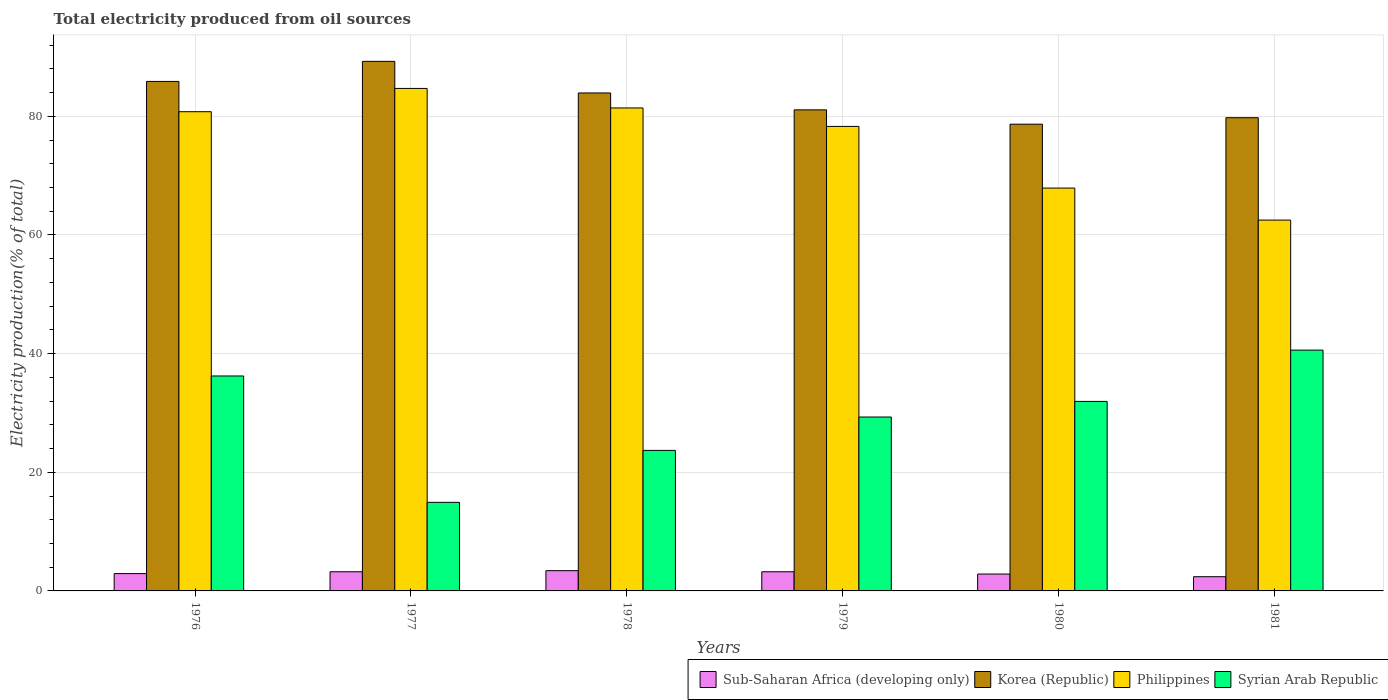How many different coloured bars are there?
Provide a succinct answer. 4. Are the number of bars on each tick of the X-axis equal?
Your answer should be compact. Yes. What is the label of the 6th group of bars from the left?
Offer a very short reply. 1981. In how many cases, is the number of bars for a given year not equal to the number of legend labels?
Ensure brevity in your answer.  0. What is the total electricity produced in Syrian Arab Republic in 1979?
Provide a short and direct response. 29.31. Across all years, what is the maximum total electricity produced in Philippines?
Ensure brevity in your answer.  84.7. Across all years, what is the minimum total electricity produced in Sub-Saharan Africa (developing only)?
Give a very brief answer. 2.39. In which year was the total electricity produced in Syrian Arab Republic maximum?
Keep it short and to the point. 1981. In which year was the total electricity produced in Korea (Republic) minimum?
Offer a very short reply. 1980. What is the total total electricity produced in Philippines in the graph?
Offer a terse response. 455.6. What is the difference between the total electricity produced in Korea (Republic) in 1976 and that in 1978?
Provide a short and direct response. 1.94. What is the difference between the total electricity produced in Sub-Saharan Africa (developing only) in 1981 and the total electricity produced in Philippines in 1980?
Provide a succinct answer. -65.51. What is the average total electricity produced in Philippines per year?
Offer a very short reply. 75.93. In the year 1977, what is the difference between the total electricity produced in Philippines and total electricity produced in Korea (Republic)?
Give a very brief answer. -4.56. What is the ratio of the total electricity produced in Philippines in 1976 to that in 1981?
Offer a terse response. 1.29. Is the difference between the total electricity produced in Philippines in 1979 and 1981 greater than the difference between the total electricity produced in Korea (Republic) in 1979 and 1981?
Your answer should be compact. Yes. What is the difference between the highest and the second highest total electricity produced in Philippines?
Ensure brevity in your answer.  3.29. What is the difference between the highest and the lowest total electricity produced in Philippines?
Offer a terse response. 22.19. Is the sum of the total electricity produced in Sub-Saharan Africa (developing only) in 1976 and 1980 greater than the maximum total electricity produced in Philippines across all years?
Keep it short and to the point. No. What does the 3rd bar from the right in 1976 represents?
Offer a terse response. Korea (Republic). What is the difference between two consecutive major ticks on the Y-axis?
Provide a succinct answer. 20. Are the values on the major ticks of Y-axis written in scientific E-notation?
Your answer should be very brief. No. Does the graph contain any zero values?
Give a very brief answer. No. Does the graph contain grids?
Provide a short and direct response. Yes. What is the title of the graph?
Provide a short and direct response. Total electricity produced from oil sources. What is the label or title of the X-axis?
Your answer should be compact. Years. What is the Electricity production(% of total) in Sub-Saharan Africa (developing only) in 1976?
Ensure brevity in your answer.  2.92. What is the Electricity production(% of total) of Korea (Republic) in 1976?
Offer a very short reply. 85.88. What is the Electricity production(% of total) in Philippines in 1976?
Offer a very short reply. 80.78. What is the Electricity production(% of total) of Syrian Arab Republic in 1976?
Offer a terse response. 36.23. What is the Electricity production(% of total) of Sub-Saharan Africa (developing only) in 1977?
Your response must be concise. 3.23. What is the Electricity production(% of total) of Korea (Republic) in 1977?
Offer a terse response. 89.27. What is the Electricity production(% of total) of Philippines in 1977?
Provide a short and direct response. 84.7. What is the Electricity production(% of total) of Syrian Arab Republic in 1977?
Offer a very short reply. 14.93. What is the Electricity production(% of total) in Sub-Saharan Africa (developing only) in 1978?
Offer a terse response. 3.41. What is the Electricity production(% of total) in Korea (Republic) in 1978?
Keep it short and to the point. 83.94. What is the Electricity production(% of total) of Philippines in 1978?
Provide a succinct answer. 81.41. What is the Electricity production(% of total) in Syrian Arab Republic in 1978?
Your answer should be compact. 23.69. What is the Electricity production(% of total) of Sub-Saharan Africa (developing only) in 1979?
Offer a terse response. 3.23. What is the Electricity production(% of total) of Korea (Republic) in 1979?
Provide a short and direct response. 81.09. What is the Electricity production(% of total) in Philippines in 1979?
Keep it short and to the point. 78.3. What is the Electricity production(% of total) in Syrian Arab Republic in 1979?
Make the answer very short. 29.31. What is the Electricity production(% of total) in Sub-Saharan Africa (developing only) in 1980?
Provide a short and direct response. 2.84. What is the Electricity production(% of total) of Korea (Republic) in 1980?
Offer a terse response. 78.67. What is the Electricity production(% of total) of Philippines in 1980?
Give a very brief answer. 67.9. What is the Electricity production(% of total) of Syrian Arab Republic in 1980?
Keep it short and to the point. 31.94. What is the Electricity production(% of total) of Sub-Saharan Africa (developing only) in 1981?
Offer a terse response. 2.39. What is the Electricity production(% of total) in Korea (Republic) in 1981?
Offer a very short reply. 79.76. What is the Electricity production(% of total) of Philippines in 1981?
Ensure brevity in your answer.  62.51. What is the Electricity production(% of total) in Syrian Arab Republic in 1981?
Your answer should be very brief. 40.59. Across all years, what is the maximum Electricity production(% of total) in Sub-Saharan Africa (developing only)?
Your answer should be very brief. 3.41. Across all years, what is the maximum Electricity production(% of total) in Korea (Republic)?
Keep it short and to the point. 89.27. Across all years, what is the maximum Electricity production(% of total) of Philippines?
Give a very brief answer. 84.7. Across all years, what is the maximum Electricity production(% of total) in Syrian Arab Republic?
Offer a very short reply. 40.59. Across all years, what is the minimum Electricity production(% of total) of Sub-Saharan Africa (developing only)?
Keep it short and to the point. 2.39. Across all years, what is the minimum Electricity production(% of total) in Korea (Republic)?
Give a very brief answer. 78.67. Across all years, what is the minimum Electricity production(% of total) in Philippines?
Make the answer very short. 62.51. Across all years, what is the minimum Electricity production(% of total) in Syrian Arab Republic?
Give a very brief answer. 14.93. What is the total Electricity production(% of total) of Sub-Saharan Africa (developing only) in the graph?
Offer a terse response. 18.04. What is the total Electricity production(% of total) in Korea (Republic) in the graph?
Your answer should be very brief. 498.61. What is the total Electricity production(% of total) in Philippines in the graph?
Provide a succinct answer. 455.6. What is the total Electricity production(% of total) of Syrian Arab Republic in the graph?
Offer a very short reply. 176.7. What is the difference between the Electricity production(% of total) in Sub-Saharan Africa (developing only) in 1976 and that in 1977?
Your response must be concise. -0.31. What is the difference between the Electricity production(% of total) of Korea (Republic) in 1976 and that in 1977?
Provide a succinct answer. -3.38. What is the difference between the Electricity production(% of total) in Philippines in 1976 and that in 1977?
Make the answer very short. -3.93. What is the difference between the Electricity production(% of total) in Syrian Arab Republic in 1976 and that in 1977?
Provide a short and direct response. 21.3. What is the difference between the Electricity production(% of total) of Sub-Saharan Africa (developing only) in 1976 and that in 1978?
Your answer should be very brief. -0.49. What is the difference between the Electricity production(% of total) in Korea (Republic) in 1976 and that in 1978?
Provide a short and direct response. 1.94. What is the difference between the Electricity production(% of total) in Philippines in 1976 and that in 1978?
Your answer should be compact. -0.64. What is the difference between the Electricity production(% of total) of Syrian Arab Republic in 1976 and that in 1978?
Ensure brevity in your answer.  12.55. What is the difference between the Electricity production(% of total) in Sub-Saharan Africa (developing only) in 1976 and that in 1979?
Offer a terse response. -0.31. What is the difference between the Electricity production(% of total) in Korea (Republic) in 1976 and that in 1979?
Ensure brevity in your answer.  4.79. What is the difference between the Electricity production(% of total) of Philippines in 1976 and that in 1979?
Your answer should be very brief. 2.48. What is the difference between the Electricity production(% of total) in Syrian Arab Republic in 1976 and that in 1979?
Your answer should be very brief. 6.92. What is the difference between the Electricity production(% of total) of Sub-Saharan Africa (developing only) in 1976 and that in 1980?
Your answer should be very brief. 0.08. What is the difference between the Electricity production(% of total) in Korea (Republic) in 1976 and that in 1980?
Offer a terse response. 7.21. What is the difference between the Electricity production(% of total) of Philippines in 1976 and that in 1980?
Ensure brevity in your answer.  12.87. What is the difference between the Electricity production(% of total) of Syrian Arab Republic in 1976 and that in 1980?
Provide a short and direct response. 4.29. What is the difference between the Electricity production(% of total) of Sub-Saharan Africa (developing only) in 1976 and that in 1981?
Provide a succinct answer. 0.53. What is the difference between the Electricity production(% of total) in Korea (Republic) in 1976 and that in 1981?
Give a very brief answer. 6.12. What is the difference between the Electricity production(% of total) in Philippines in 1976 and that in 1981?
Provide a succinct answer. 18.27. What is the difference between the Electricity production(% of total) in Syrian Arab Republic in 1976 and that in 1981?
Ensure brevity in your answer.  -4.36. What is the difference between the Electricity production(% of total) in Sub-Saharan Africa (developing only) in 1977 and that in 1978?
Give a very brief answer. -0.19. What is the difference between the Electricity production(% of total) of Korea (Republic) in 1977 and that in 1978?
Your answer should be compact. 5.33. What is the difference between the Electricity production(% of total) in Philippines in 1977 and that in 1978?
Provide a short and direct response. 3.29. What is the difference between the Electricity production(% of total) of Syrian Arab Republic in 1977 and that in 1978?
Keep it short and to the point. -8.76. What is the difference between the Electricity production(% of total) in Sub-Saharan Africa (developing only) in 1977 and that in 1979?
Offer a terse response. 0. What is the difference between the Electricity production(% of total) in Korea (Republic) in 1977 and that in 1979?
Provide a succinct answer. 8.18. What is the difference between the Electricity production(% of total) of Philippines in 1977 and that in 1979?
Keep it short and to the point. 6.4. What is the difference between the Electricity production(% of total) in Syrian Arab Republic in 1977 and that in 1979?
Offer a very short reply. -14.38. What is the difference between the Electricity production(% of total) of Sub-Saharan Africa (developing only) in 1977 and that in 1980?
Your answer should be compact. 0.39. What is the difference between the Electricity production(% of total) in Korea (Republic) in 1977 and that in 1980?
Make the answer very short. 10.59. What is the difference between the Electricity production(% of total) of Philippines in 1977 and that in 1980?
Your answer should be compact. 16.8. What is the difference between the Electricity production(% of total) of Syrian Arab Republic in 1977 and that in 1980?
Your answer should be very brief. -17.02. What is the difference between the Electricity production(% of total) of Sub-Saharan Africa (developing only) in 1977 and that in 1981?
Ensure brevity in your answer.  0.84. What is the difference between the Electricity production(% of total) in Korea (Republic) in 1977 and that in 1981?
Provide a short and direct response. 9.5. What is the difference between the Electricity production(% of total) in Philippines in 1977 and that in 1981?
Keep it short and to the point. 22.19. What is the difference between the Electricity production(% of total) in Syrian Arab Republic in 1977 and that in 1981?
Make the answer very short. -25.66. What is the difference between the Electricity production(% of total) of Sub-Saharan Africa (developing only) in 1978 and that in 1979?
Your response must be concise. 0.19. What is the difference between the Electricity production(% of total) in Korea (Republic) in 1978 and that in 1979?
Your answer should be very brief. 2.85. What is the difference between the Electricity production(% of total) in Philippines in 1978 and that in 1979?
Offer a very short reply. 3.11. What is the difference between the Electricity production(% of total) of Syrian Arab Republic in 1978 and that in 1979?
Your answer should be compact. -5.63. What is the difference between the Electricity production(% of total) in Sub-Saharan Africa (developing only) in 1978 and that in 1980?
Offer a very short reply. 0.57. What is the difference between the Electricity production(% of total) of Korea (Republic) in 1978 and that in 1980?
Give a very brief answer. 5.27. What is the difference between the Electricity production(% of total) in Philippines in 1978 and that in 1980?
Keep it short and to the point. 13.51. What is the difference between the Electricity production(% of total) in Syrian Arab Republic in 1978 and that in 1980?
Make the answer very short. -8.26. What is the difference between the Electricity production(% of total) in Sub-Saharan Africa (developing only) in 1978 and that in 1981?
Offer a terse response. 1.02. What is the difference between the Electricity production(% of total) in Korea (Republic) in 1978 and that in 1981?
Your answer should be compact. 4.17. What is the difference between the Electricity production(% of total) of Philippines in 1978 and that in 1981?
Keep it short and to the point. 18.9. What is the difference between the Electricity production(% of total) of Syrian Arab Republic in 1978 and that in 1981?
Offer a terse response. -16.91. What is the difference between the Electricity production(% of total) of Sub-Saharan Africa (developing only) in 1979 and that in 1980?
Provide a short and direct response. 0.38. What is the difference between the Electricity production(% of total) in Korea (Republic) in 1979 and that in 1980?
Provide a succinct answer. 2.42. What is the difference between the Electricity production(% of total) of Philippines in 1979 and that in 1980?
Ensure brevity in your answer.  10.39. What is the difference between the Electricity production(% of total) in Syrian Arab Republic in 1979 and that in 1980?
Provide a succinct answer. -2.63. What is the difference between the Electricity production(% of total) of Sub-Saharan Africa (developing only) in 1979 and that in 1981?
Your answer should be very brief. 0.84. What is the difference between the Electricity production(% of total) in Korea (Republic) in 1979 and that in 1981?
Your answer should be very brief. 1.33. What is the difference between the Electricity production(% of total) in Philippines in 1979 and that in 1981?
Keep it short and to the point. 15.79. What is the difference between the Electricity production(% of total) in Syrian Arab Republic in 1979 and that in 1981?
Offer a terse response. -11.28. What is the difference between the Electricity production(% of total) in Sub-Saharan Africa (developing only) in 1980 and that in 1981?
Your answer should be very brief. 0.45. What is the difference between the Electricity production(% of total) in Korea (Republic) in 1980 and that in 1981?
Your answer should be very brief. -1.09. What is the difference between the Electricity production(% of total) in Philippines in 1980 and that in 1981?
Your answer should be very brief. 5.4. What is the difference between the Electricity production(% of total) of Syrian Arab Republic in 1980 and that in 1981?
Your answer should be very brief. -8.65. What is the difference between the Electricity production(% of total) of Sub-Saharan Africa (developing only) in 1976 and the Electricity production(% of total) of Korea (Republic) in 1977?
Offer a very short reply. -86.34. What is the difference between the Electricity production(% of total) in Sub-Saharan Africa (developing only) in 1976 and the Electricity production(% of total) in Philippines in 1977?
Offer a very short reply. -81.78. What is the difference between the Electricity production(% of total) in Sub-Saharan Africa (developing only) in 1976 and the Electricity production(% of total) in Syrian Arab Republic in 1977?
Make the answer very short. -12.01. What is the difference between the Electricity production(% of total) in Korea (Republic) in 1976 and the Electricity production(% of total) in Philippines in 1977?
Your answer should be compact. 1.18. What is the difference between the Electricity production(% of total) in Korea (Republic) in 1976 and the Electricity production(% of total) in Syrian Arab Republic in 1977?
Make the answer very short. 70.95. What is the difference between the Electricity production(% of total) of Philippines in 1976 and the Electricity production(% of total) of Syrian Arab Republic in 1977?
Offer a terse response. 65.85. What is the difference between the Electricity production(% of total) in Sub-Saharan Africa (developing only) in 1976 and the Electricity production(% of total) in Korea (Republic) in 1978?
Your answer should be compact. -81.02. What is the difference between the Electricity production(% of total) in Sub-Saharan Africa (developing only) in 1976 and the Electricity production(% of total) in Philippines in 1978?
Make the answer very short. -78.49. What is the difference between the Electricity production(% of total) of Sub-Saharan Africa (developing only) in 1976 and the Electricity production(% of total) of Syrian Arab Republic in 1978?
Ensure brevity in your answer.  -20.76. What is the difference between the Electricity production(% of total) in Korea (Republic) in 1976 and the Electricity production(% of total) in Philippines in 1978?
Your answer should be compact. 4.47. What is the difference between the Electricity production(% of total) in Korea (Republic) in 1976 and the Electricity production(% of total) in Syrian Arab Republic in 1978?
Offer a terse response. 62.2. What is the difference between the Electricity production(% of total) of Philippines in 1976 and the Electricity production(% of total) of Syrian Arab Republic in 1978?
Provide a short and direct response. 57.09. What is the difference between the Electricity production(% of total) in Sub-Saharan Africa (developing only) in 1976 and the Electricity production(% of total) in Korea (Republic) in 1979?
Make the answer very short. -78.17. What is the difference between the Electricity production(% of total) of Sub-Saharan Africa (developing only) in 1976 and the Electricity production(% of total) of Philippines in 1979?
Your answer should be very brief. -75.38. What is the difference between the Electricity production(% of total) of Sub-Saharan Africa (developing only) in 1976 and the Electricity production(% of total) of Syrian Arab Republic in 1979?
Offer a very short reply. -26.39. What is the difference between the Electricity production(% of total) in Korea (Republic) in 1976 and the Electricity production(% of total) in Philippines in 1979?
Provide a short and direct response. 7.58. What is the difference between the Electricity production(% of total) of Korea (Republic) in 1976 and the Electricity production(% of total) of Syrian Arab Republic in 1979?
Ensure brevity in your answer.  56.57. What is the difference between the Electricity production(% of total) in Philippines in 1976 and the Electricity production(% of total) in Syrian Arab Republic in 1979?
Your answer should be compact. 51.46. What is the difference between the Electricity production(% of total) of Sub-Saharan Africa (developing only) in 1976 and the Electricity production(% of total) of Korea (Republic) in 1980?
Ensure brevity in your answer.  -75.75. What is the difference between the Electricity production(% of total) in Sub-Saharan Africa (developing only) in 1976 and the Electricity production(% of total) in Philippines in 1980?
Your answer should be compact. -64.98. What is the difference between the Electricity production(% of total) of Sub-Saharan Africa (developing only) in 1976 and the Electricity production(% of total) of Syrian Arab Republic in 1980?
Offer a very short reply. -29.02. What is the difference between the Electricity production(% of total) in Korea (Republic) in 1976 and the Electricity production(% of total) in Philippines in 1980?
Provide a short and direct response. 17.98. What is the difference between the Electricity production(% of total) in Korea (Republic) in 1976 and the Electricity production(% of total) in Syrian Arab Republic in 1980?
Your answer should be very brief. 53.94. What is the difference between the Electricity production(% of total) in Philippines in 1976 and the Electricity production(% of total) in Syrian Arab Republic in 1980?
Provide a succinct answer. 48.83. What is the difference between the Electricity production(% of total) of Sub-Saharan Africa (developing only) in 1976 and the Electricity production(% of total) of Korea (Republic) in 1981?
Ensure brevity in your answer.  -76.84. What is the difference between the Electricity production(% of total) of Sub-Saharan Africa (developing only) in 1976 and the Electricity production(% of total) of Philippines in 1981?
Keep it short and to the point. -59.59. What is the difference between the Electricity production(% of total) in Sub-Saharan Africa (developing only) in 1976 and the Electricity production(% of total) in Syrian Arab Republic in 1981?
Provide a succinct answer. -37.67. What is the difference between the Electricity production(% of total) in Korea (Republic) in 1976 and the Electricity production(% of total) in Philippines in 1981?
Give a very brief answer. 23.37. What is the difference between the Electricity production(% of total) in Korea (Republic) in 1976 and the Electricity production(% of total) in Syrian Arab Republic in 1981?
Provide a short and direct response. 45.29. What is the difference between the Electricity production(% of total) of Philippines in 1976 and the Electricity production(% of total) of Syrian Arab Republic in 1981?
Offer a very short reply. 40.18. What is the difference between the Electricity production(% of total) of Sub-Saharan Africa (developing only) in 1977 and the Electricity production(% of total) of Korea (Republic) in 1978?
Your response must be concise. -80.71. What is the difference between the Electricity production(% of total) in Sub-Saharan Africa (developing only) in 1977 and the Electricity production(% of total) in Philippines in 1978?
Keep it short and to the point. -78.18. What is the difference between the Electricity production(% of total) of Sub-Saharan Africa (developing only) in 1977 and the Electricity production(% of total) of Syrian Arab Republic in 1978?
Provide a short and direct response. -20.46. What is the difference between the Electricity production(% of total) in Korea (Republic) in 1977 and the Electricity production(% of total) in Philippines in 1978?
Your response must be concise. 7.85. What is the difference between the Electricity production(% of total) of Korea (Republic) in 1977 and the Electricity production(% of total) of Syrian Arab Republic in 1978?
Ensure brevity in your answer.  65.58. What is the difference between the Electricity production(% of total) of Philippines in 1977 and the Electricity production(% of total) of Syrian Arab Republic in 1978?
Keep it short and to the point. 61.02. What is the difference between the Electricity production(% of total) in Sub-Saharan Africa (developing only) in 1977 and the Electricity production(% of total) in Korea (Republic) in 1979?
Ensure brevity in your answer.  -77.86. What is the difference between the Electricity production(% of total) of Sub-Saharan Africa (developing only) in 1977 and the Electricity production(% of total) of Philippines in 1979?
Ensure brevity in your answer.  -75.07. What is the difference between the Electricity production(% of total) in Sub-Saharan Africa (developing only) in 1977 and the Electricity production(% of total) in Syrian Arab Republic in 1979?
Your answer should be compact. -26.08. What is the difference between the Electricity production(% of total) in Korea (Republic) in 1977 and the Electricity production(% of total) in Philippines in 1979?
Your answer should be compact. 10.97. What is the difference between the Electricity production(% of total) in Korea (Republic) in 1977 and the Electricity production(% of total) in Syrian Arab Republic in 1979?
Provide a succinct answer. 59.95. What is the difference between the Electricity production(% of total) of Philippines in 1977 and the Electricity production(% of total) of Syrian Arab Republic in 1979?
Provide a short and direct response. 55.39. What is the difference between the Electricity production(% of total) of Sub-Saharan Africa (developing only) in 1977 and the Electricity production(% of total) of Korea (Republic) in 1980?
Provide a short and direct response. -75.44. What is the difference between the Electricity production(% of total) of Sub-Saharan Africa (developing only) in 1977 and the Electricity production(% of total) of Philippines in 1980?
Offer a terse response. -64.68. What is the difference between the Electricity production(% of total) in Sub-Saharan Africa (developing only) in 1977 and the Electricity production(% of total) in Syrian Arab Republic in 1980?
Offer a terse response. -28.71. What is the difference between the Electricity production(% of total) in Korea (Republic) in 1977 and the Electricity production(% of total) in Philippines in 1980?
Make the answer very short. 21.36. What is the difference between the Electricity production(% of total) of Korea (Republic) in 1977 and the Electricity production(% of total) of Syrian Arab Republic in 1980?
Offer a very short reply. 57.32. What is the difference between the Electricity production(% of total) in Philippines in 1977 and the Electricity production(% of total) in Syrian Arab Republic in 1980?
Your answer should be very brief. 52.76. What is the difference between the Electricity production(% of total) in Sub-Saharan Africa (developing only) in 1977 and the Electricity production(% of total) in Korea (Republic) in 1981?
Provide a short and direct response. -76.54. What is the difference between the Electricity production(% of total) of Sub-Saharan Africa (developing only) in 1977 and the Electricity production(% of total) of Philippines in 1981?
Provide a succinct answer. -59.28. What is the difference between the Electricity production(% of total) in Sub-Saharan Africa (developing only) in 1977 and the Electricity production(% of total) in Syrian Arab Republic in 1981?
Your answer should be very brief. -37.36. What is the difference between the Electricity production(% of total) of Korea (Republic) in 1977 and the Electricity production(% of total) of Philippines in 1981?
Your answer should be compact. 26.76. What is the difference between the Electricity production(% of total) of Korea (Republic) in 1977 and the Electricity production(% of total) of Syrian Arab Republic in 1981?
Your response must be concise. 48.67. What is the difference between the Electricity production(% of total) of Philippines in 1977 and the Electricity production(% of total) of Syrian Arab Republic in 1981?
Make the answer very short. 44.11. What is the difference between the Electricity production(% of total) in Sub-Saharan Africa (developing only) in 1978 and the Electricity production(% of total) in Korea (Republic) in 1979?
Make the answer very short. -77.68. What is the difference between the Electricity production(% of total) in Sub-Saharan Africa (developing only) in 1978 and the Electricity production(% of total) in Philippines in 1979?
Your response must be concise. -74.88. What is the difference between the Electricity production(% of total) of Sub-Saharan Africa (developing only) in 1978 and the Electricity production(% of total) of Syrian Arab Republic in 1979?
Provide a short and direct response. -25.9. What is the difference between the Electricity production(% of total) of Korea (Republic) in 1978 and the Electricity production(% of total) of Philippines in 1979?
Keep it short and to the point. 5.64. What is the difference between the Electricity production(% of total) in Korea (Republic) in 1978 and the Electricity production(% of total) in Syrian Arab Republic in 1979?
Your answer should be compact. 54.63. What is the difference between the Electricity production(% of total) of Philippines in 1978 and the Electricity production(% of total) of Syrian Arab Republic in 1979?
Your answer should be very brief. 52.1. What is the difference between the Electricity production(% of total) of Sub-Saharan Africa (developing only) in 1978 and the Electricity production(% of total) of Korea (Republic) in 1980?
Provide a succinct answer. -75.26. What is the difference between the Electricity production(% of total) of Sub-Saharan Africa (developing only) in 1978 and the Electricity production(% of total) of Philippines in 1980?
Provide a short and direct response. -64.49. What is the difference between the Electricity production(% of total) of Sub-Saharan Africa (developing only) in 1978 and the Electricity production(% of total) of Syrian Arab Republic in 1980?
Give a very brief answer. -28.53. What is the difference between the Electricity production(% of total) in Korea (Republic) in 1978 and the Electricity production(% of total) in Philippines in 1980?
Your answer should be very brief. 16.03. What is the difference between the Electricity production(% of total) in Korea (Republic) in 1978 and the Electricity production(% of total) in Syrian Arab Republic in 1980?
Offer a very short reply. 51.99. What is the difference between the Electricity production(% of total) of Philippines in 1978 and the Electricity production(% of total) of Syrian Arab Republic in 1980?
Keep it short and to the point. 49.47. What is the difference between the Electricity production(% of total) of Sub-Saharan Africa (developing only) in 1978 and the Electricity production(% of total) of Korea (Republic) in 1981?
Your answer should be compact. -76.35. What is the difference between the Electricity production(% of total) in Sub-Saharan Africa (developing only) in 1978 and the Electricity production(% of total) in Philippines in 1981?
Keep it short and to the point. -59.09. What is the difference between the Electricity production(% of total) of Sub-Saharan Africa (developing only) in 1978 and the Electricity production(% of total) of Syrian Arab Republic in 1981?
Offer a very short reply. -37.18. What is the difference between the Electricity production(% of total) of Korea (Republic) in 1978 and the Electricity production(% of total) of Philippines in 1981?
Offer a very short reply. 21.43. What is the difference between the Electricity production(% of total) of Korea (Republic) in 1978 and the Electricity production(% of total) of Syrian Arab Republic in 1981?
Your answer should be very brief. 43.35. What is the difference between the Electricity production(% of total) in Philippines in 1978 and the Electricity production(% of total) in Syrian Arab Republic in 1981?
Your answer should be very brief. 40.82. What is the difference between the Electricity production(% of total) of Sub-Saharan Africa (developing only) in 1979 and the Electricity production(% of total) of Korea (Republic) in 1980?
Offer a very short reply. -75.44. What is the difference between the Electricity production(% of total) of Sub-Saharan Africa (developing only) in 1979 and the Electricity production(% of total) of Philippines in 1980?
Keep it short and to the point. -64.68. What is the difference between the Electricity production(% of total) in Sub-Saharan Africa (developing only) in 1979 and the Electricity production(% of total) in Syrian Arab Republic in 1980?
Give a very brief answer. -28.72. What is the difference between the Electricity production(% of total) in Korea (Republic) in 1979 and the Electricity production(% of total) in Philippines in 1980?
Make the answer very short. 13.19. What is the difference between the Electricity production(% of total) in Korea (Republic) in 1979 and the Electricity production(% of total) in Syrian Arab Republic in 1980?
Offer a terse response. 49.15. What is the difference between the Electricity production(% of total) in Philippines in 1979 and the Electricity production(% of total) in Syrian Arab Republic in 1980?
Ensure brevity in your answer.  46.35. What is the difference between the Electricity production(% of total) in Sub-Saharan Africa (developing only) in 1979 and the Electricity production(% of total) in Korea (Republic) in 1981?
Give a very brief answer. -76.54. What is the difference between the Electricity production(% of total) in Sub-Saharan Africa (developing only) in 1979 and the Electricity production(% of total) in Philippines in 1981?
Offer a very short reply. -59.28. What is the difference between the Electricity production(% of total) in Sub-Saharan Africa (developing only) in 1979 and the Electricity production(% of total) in Syrian Arab Republic in 1981?
Ensure brevity in your answer.  -37.36. What is the difference between the Electricity production(% of total) of Korea (Republic) in 1979 and the Electricity production(% of total) of Philippines in 1981?
Provide a succinct answer. 18.58. What is the difference between the Electricity production(% of total) of Korea (Republic) in 1979 and the Electricity production(% of total) of Syrian Arab Republic in 1981?
Provide a succinct answer. 40.5. What is the difference between the Electricity production(% of total) in Philippines in 1979 and the Electricity production(% of total) in Syrian Arab Republic in 1981?
Your response must be concise. 37.71. What is the difference between the Electricity production(% of total) in Sub-Saharan Africa (developing only) in 1980 and the Electricity production(% of total) in Korea (Republic) in 1981?
Provide a succinct answer. -76.92. What is the difference between the Electricity production(% of total) in Sub-Saharan Africa (developing only) in 1980 and the Electricity production(% of total) in Philippines in 1981?
Offer a terse response. -59.66. What is the difference between the Electricity production(% of total) in Sub-Saharan Africa (developing only) in 1980 and the Electricity production(% of total) in Syrian Arab Republic in 1981?
Make the answer very short. -37.75. What is the difference between the Electricity production(% of total) in Korea (Republic) in 1980 and the Electricity production(% of total) in Philippines in 1981?
Provide a succinct answer. 16.16. What is the difference between the Electricity production(% of total) of Korea (Republic) in 1980 and the Electricity production(% of total) of Syrian Arab Republic in 1981?
Offer a terse response. 38.08. What is the difference between the Electricity production(% of total) of Philippines in 1980 and the Electricity production(% of total) of Syrian Arab Republic in 1981?
Keep it short and to the point. 27.31. What is the average Electricity production(% of total) of Sub-Saharan Africa (developing only) per year?
Keep it short and to the point. 3.01. What is the average Electricity production(% of total) in Korea (Republic) per year?
Make the answer very short. 83.1. What is the average Electricity production(% of total) in Philippines per year?
Keep it short and to the point. 75.93. What is the average Electricity production(% of total) of Syrian Arab Republic per year?
Keep it short and to the point. 29.45. In the year 1976, what is the difference between the Electricity production(% of total) in Sub-Saharan Africa (developing only) and Electricity production(% of total) in Korea (Republic)?
Give a very brief answer. -82.96. In the year 1976, what is the difference between the Electricity production(% of total) of Sub-Saharan Africa (developing only) and Electricity production(% of total) of Philippines?
Your answer should be compact. -77.85. In the year 1976, what is the difference between the Electricity production(% of total) of Sub-Saharan Africa (developing only) and Electricity production(% of total) of Syrian Arab Republic?
Provide a succinct answer. -33.31. In the year 1976, what is the difference between the Electricity production(% of total) in Korea (Republic) and Electricity production(% of total) in Philippines?
Provide a short and direct response. 5.1. In the year 1976, what is the difference between the Electricity production(% of total) in Korea (Republic) and Electricity production(% of total) in Syrian Arab Republic?
Your answer should be very brief. 49.65. In the year 1976, what is the difference between the Electricity production(% of total) of Philippines and Electricity production(% of total) of Syrian Arab Republic?
Offer a very short reply. 44.54. In the year 1977, what is the difference between the Electricity production(% of total) in Sub-Saharan Africa (developing only) and Electricity production(% of total) in Korea (Republic)?
Provide a succinct answer. -86.04. In the year 1977, what is the difference between the Electricity production(% of total) in Sub-Saharan Africa (developing only) and Electricity production(% of total) in Philippines?
Make the answer very short. -81.47. In the year 1977, what is the difference between the Electricity production(% of total) in Sub-Saharan Africa (developing only) and Electricity production(% of total) in Syrian Arab Republic?
Provide a succinct answer. -11.7. In the year 1977, what is the difference between the Electricity production(% of total) in Korea (Republic) and Electricity production(% of total) in Philippines?
Your response must be concise. 4.56. In the year 1977, what is the difference between the Electricity production(% of total) of Korea (Republic) and Electricity production(% of total) of Syrian Arab Republic?
Make the answer very short. 74.34. In the year 1977, what is the difference between the Electricity production(% of total) in Philippines and Electricity production(% of total) in Syrian Arab Republic?
Ensure brevity in your answer.  69.77. In the year 1978, what is the difference between the Electricity production(% of total) in Sub-Saharan Africa (developing only) and Electricity production(% of total) in Korea (Republic)?
Provide a succinct answer. -80.52. In the year 1978, what is the difference between the Electricity production(% of total) of Sub-Saharan Africa (developing only) and Electricity production(% of total) of Philippines?
Offer a terse response. -78. In the year 1978, what is the difference between the Electricity production(% of total) of Sub-Saharan Africa (developing only) and Electricity production(% of total) of Syrian Arab Republic?
Give a very brief answer. -20.27. In the year 1978, what is the difference between the Electricity production(% of total) in Korea (Republic) and Electricity production(% of total) in Philippines?
Provide a succinct answer. 2.53. In the year 1978, what is the difference between the Electricity production(% of total) in Korea (Republic) and Electricity production(% of total) in Syrian Arab Republic?
Provide a short and direct response. 60.25. In the year 1978, what is the difference between the Electricity production(% of total) of Philippines and Electricity production(% of total) of Syrian Arab Republic?
Your answer should be very brief. 57.73. In the year 1979, what is the difference between the Electricity production(% of total) in Sub-Saharan Africa (developing only) and Electricity production(% of total) in Korea (Republic)?
Provide a short and direct response. -77.86. In the year 1979, what is the difference between the Electricity production(% of total) in Sub-Saharan Africa (developing only) and Electricity production(% of total) in Philippines?
Ensure brevity in your answer.  -75.07. In the year 1979, what is the difference between the Electricity production(% of total) of Sub-Saharan Africa (developing only) and Electricity production(% of total) of Syrian Arab Republic?
Offer a very short reply. -26.08. In the year 1979, what is the difference between the Electricity production(% of total) in Korea (Republic) and Electricity production(% of total) in Philippines?
Give a very brief answer. 2.79. In the year 1979, what is the difference between the Electricity production(% of total) in Korea (Republic) and Electricity production(% of total) in Syrian Arab Republic?
Ensure brevity in your answer.  51.78. In the year 1979, what is the difference between the Electricity production(% of total) in Philippines and Electricity production(% of total) in Syrian Arab Republic?
Provide a succinct answer. 48.99. In the year 1980, what is the difference between the Electricity production(% of total) of Sub-Saharan Africa (developing only) and Electricity production(% of total) of Korea (Republic)?
Ensure brevity in your answer.  -75.83. In the year 1980, what is the difference between the Electricity production(% of total) of Sub-Saharan Africa (developing only) and Electricity production(% of total) of Philippines?
Your response must be concise. -65.06. In the year 1980, what is the difference between the Electricity production(% of total) of Sub-Saharan Africa (developing only) and Electricity production(% of total) of Syrian Arab Republic?
Your answer should be very brief. -29.1. In the year 1980, what is the difference between the Electricity production(% of total) in Korea (Republic) and Electricity production(% of total) in Philippines?
Ensure brevity in your answer.  10.77. In the year 1980, what is the difference between the Electricity production(% of total) in Korea (Republic) and Electricity production(% of total) in Syrian Arab Republic?
Give a very brief answer. 46.73. In the year 1980, what is the difference between the Electricity production(% of total) in Philippines and Electricity production(% of total) in Syrian Arab Republic?
Provide a short and direct response. 35.96. In the year 1981, what is the difference between the Electricity production(% of total) of Sub-Saharan Africa (developing only) and Electricity production(% of total) of Korea (Republic)?
Provide a succinct answer. -77.37. In the year 1981, what is the difference between the Electricity production(% of total) in Sub-Saharan Africa (developing only) and Electricity production(% of total) in Philippines?
Your answer should be very brief. -60.11. In the year 1981, what is the difference between the Electricity production(% of total) of Sub-Saharan Africa (developing only) and Electricity production(% of total) of Syrian Arab Republic?
Ensure brevity in your answer.  -38.2. In the year 1981, what is the difference between the Electricity production(% of total) of Korea (Republic) and Electricity production(% of total) of Philippines?
Give a very brief answer. 17.26. In the year 1981, what is the difference between the Electricity production(% of total) in Korea (Republic) and Electricity production(% of total) in Syrian Arab Republic?
Provide a short and direct response. 39.17. In the year 1981, what is the difference between the Electricity production(% of total) of Philippines and Electricity production(% of total) of Syrian Arab Republic?
Keep it short and to the point. 21.92. What is the ratio of the Electricity production(% of total) in Sub-Saharan Africa (developing only) in 1976 to that in 1977?
Ensure brevity in your answer.  0.91. What is the ratio of the Electricity production(% of total) in Korea (Republic) in 1976 to that in 1977?
Give a very brief answer. 0.96. What is the ratio of the Electricity production(% of total) in Philippines in 1976 to that in 1977?
Give a very brief answer. 0.95. What is the ratio of the Electricity production(% of total) of Syrian Arab Republic in 1976 to that in 1977?
Ensure brevity in your answer.  2.43. What is the ratio of the Electricity production(% of total) of Sub-Saharan Africa (developing only) in 1976 to that in 1978?
Your answer should be very brief. 0.86. What is the ratio of the Electricity production(% of total) of Korea (Republic) in 1976 to that in 1978?
Offer a very short reply. 1.02. What is the ratio of the Electricity production(% of total) of Syrian Arab Republic in 1976 to that in 1978?
Your response must be concise. 1.53. What is the ratio of the Electricity production(% of total) in Sub-Saharan Africa (developing only) in 1976 to that in 1979?
Your answer should be very brief. 0.91. What is the ratio of the Electricity production(% of total) of Korea (Republic) in 1976 to that in 1979?
Provide a succinct answer. 1.06. What is the ratio of the Electricity production(% of total) in Philippines in 1976 to that in 1979?
Offer a very short reply. 1.03. What is the ratio of the Electricity production(% of total) of Syrian Arab Republic in 1976 to that in 1979?
Provide a succinct answer. 1.24. What is the ratio of the Electricity production(% of total) of Sub-Saharan Africa (developing only) in 1976 to that in 1980?
Provide a short and direct response. 1.03. What is the ratio of the Electricity production(% of total) in Korea (Republic) in 1976 to that in 1980?
Offer a very short reply. 1.09. What is the ratio of the Electricity production(% of total) in Philippines in 1976 to that in 1980?
Keep it short and to the point. 1.19. What is the ratio of the Electricity production(% of total) in Syrian Arab Republic in 1976 to that in 1980?
Your answer should be very brief. 1.13. What is the ratio of the Electricity production(% of total) in Sub-Saharan Africa (developing only) in 1976 to that in 1981?
Make the answer very short. 1.22. What is the ratio of the Electricity production(% of total) of Korea (Republic) in 1976 to that in 1981?
Offer a terse response. 1.08. What is the ratio of the Electricity production(% of total) of Philippines in 1976 to that in 1981?
Keep it short and to the point. 1.29. What is the ratio of the Electricity production(% of total) of Syrian Arab Republic in 1976 to that in 1981?
Make the answer very short. 0.89. What is the ratio of the Electricity production(% of total) in Sub-Saharan Africa (developing only) in 1977 to that in 1978?
Make the answer very short. 0.95. What is the ratio of the Electricity production(% of total) of Korea (Republic) in 1977 to that in 1978?
Your response must be concise. 1.06. What is the ratio of the Electricity production(% of total) in Philippines in 1977 to that in 1978?
Your answer should be compact. 1.04. What is the ratio of the Electricity production(% of total) in Syrian Arab Republic in 1977 to that in 1978?
Keep it short and to the point. 0.63. What is the ratio of the Electricity production(% of total) of Sub-Saharan Africa (developing only) in 1977 to that in 1979?
Your answer should be compact. 1. What is the ratio of the Electricity production(% of total) of Korea (Republic) in 1977 to that in 1979?
Offer a very short reply. 1.1. What is the ratio of the Electricity production(% of total) in Philippines in 1977 to that in 1979?
Provide a succinct answer. 1.08. What is the ratio of the Electricity production(% of total) in Syrian Arab Republic in 1977 to that in 1979?
Ensure brevity in your answer.  0.51. What is the ratio of the Electricity production(% of total) of Sub-Saharan Africa (developing only) in 1977 to that in 1980?
Give a very brief answer. 1.14. What is the ratio of the Electricity production(% of total) of Korea (Republic) in 1977 to that in 1980?
Ensure brevity in your answer.  1.13. What is the ratio of the Electricity production(% of total) in Philippines in 1977 to that in 1980?
Provide a short and direct response. 1.25. What is the ratio of the Electricity production(% of total) in Syrian Arab Republic in 1977 to that in 1980?
Give a very brief answer. 0.47. What is the ratio of the Electricity production(% of total) in Sub-Saharan Africa (developing only) in 1977 to that in 1981?
Your answer should be very brief. 1.35. What is the ratio of the Electricity production(% of total) of Korea (Republic) in 1977 to that in 1981?
Keep it short and to the point. 1.12. What is the ratio of the Electricity production(% of total) of Philippines in 1977 to that in 1981?
Offer a terse response. 1.35. What is the ratio of the Electricity production(% of total) in Syrian Arab Republic in 1977 to that in 1981?
Provide a short and direct response. 0.37. What is the ratio of the Electricity production(% of total) of Sub-Saharan Africa (developing only) in 1978 to that in 1979?
Provide a succinct answer. 1.06. What is the ratio of the Electricity production(% of total) in Korea (Republic) in 1978 to that in 1979?
Offer a terse response. 1.04. What is the ratio of the Electricity production(% of total) of Philippines in 1978 to that in 1979?
Provide a succinct answer. 1.04. What is the ratio of the Electricity production(% of total) in Syrian Arab Republic in 1978 to that in 1979?
Ensure brevity in your answer.  0.81. What is the ratio of the Electricity production(% of total) of Sub-Saharan Africa (developing only) in 1978 to that in 1980?
Provide a short and direct response. 1.2. What is the ratio of the Electricity production(% of total) in Korea (Republic) in 1978 to that in 1980?
Offer a terse response. 1.07. What is the ratio of the Electricity production(% of total) in Philippines in 1978 to that in 1980?
Ensure brevity in your answer.  1.2. What is the ratio of the Electricity production(% of total) of Syrian Arab Republic in 1978 to that in 1980?
Your answer should be very brief. 0.74. What is the ratio of the Electricity production(% of total) in Sub-Saharan Africa (developing only) in 1978 to that in 1981?
Offer a terse response. 1.43. What is the ratio of the Electricity production(% of total) in Korea (Republic) in 1978 to that in 1981?
Ensure brevity in your answer.  1.05. What is the ratio of the Electricity production(% of total) in Philippines in 1978 to that in 1981?
Provide a succinct answer. 1.3. What is the ratio of the Electricity production(% of total) in Syrian Arab Republic in 1978 to that in 1981?
Make the answer very short. 0.58. What is the ratio of the Electricity production(% of total) in Sub-Saharan Africa (developing only) in 1979 to that in 1980?
Provide a succinct answer. 1.14. What is the ratio of the Electricity production(% of total) of Korea (Republic) in 1979 to that in 1980?
Ensure brevity in your answer.  1.03. What is the ratio of the Electricity production(% of total) in Philippines in 1979 to that in 1980?
Provide a short and direct response. 1.15. What is the ratio of the Electricity production(% of total) of Syrian Arab Republic in 1979 to that in 1980?
Make the answer very short. 0.92. What is the ratio of the Electricity production(% of total) in Sub-Saharan Africa (developing only) in 1979 to that in 1981?
Provide a succinct answer. 1.35. What is the ratio of the Electricity production(% of total) in Korea (Republic) in 1979 to that in 1981?
Provide a short and direct response. 1.02. What is the ratio of the Electricity production(% of total) of Philippines in 1979 to that in 1981?
Give a very brief answer. 1.25. What is the ratio of the Electricity production(% of total) of Syrian Arab Republic in 1979 to that in 1981?
Your response must be concise. 0.72. What is the ratio of the Electricity production(% of total) in Sub-Saharan Africa (developing only) in 1980 to that in 1981?
Ensure brevity in your answer.  1.19. What is the ratio of the Electricity production(% of total) in Korea (Republic) in 1980 to that in 1981?
Your response must be concise. 0.99. What is the ratio of the Electricity production(% of total) in Philippines in 1980 to that in 1981?
Provide a short and direct response. 1.09. What is the ratio of the Electricity production(% of total) in Syrian Arab Republic in 1980 to that in 1981?
Your answer should be compact. 0.79. What is the difference between the highest and the second highest Electricity production(% of total) of Sub-Saharan Africa (developing only)?
Provide a succinct answer. 0.19. What is the difference between the highest and the second highest Electricity production(% of total) in Korea (Republic)?
Your response must be concise. 3.38. What is the difference between the highest and the second highest Electricity production(% of total) of Philippines?
Your answer should be very brief. 3.29. What is the difference between the highest and the second highest Electricity production(% of total) in Syrian Arab Republic?
Your answer should be very brief. 4.36. What is the difference between the highest and the lowest Electricity production(% of total) of Sub-Saharan Africa (developing only)?
Keep it short and to the point. 1.02. What is the difference between the highest and the lowest Electricity production(% of total) of Korea (Republic)?
Your answer should be very brief. 10.59. What is the difference between the highest and the lowest Electricity production(% of total) of Philippines?
Keep it short and to the point. 22.19. What is the difference between the highest and the lowest Electricity production(% of total) of Syrian Arab Republic?
Keep it short and to the point. 25.66. 